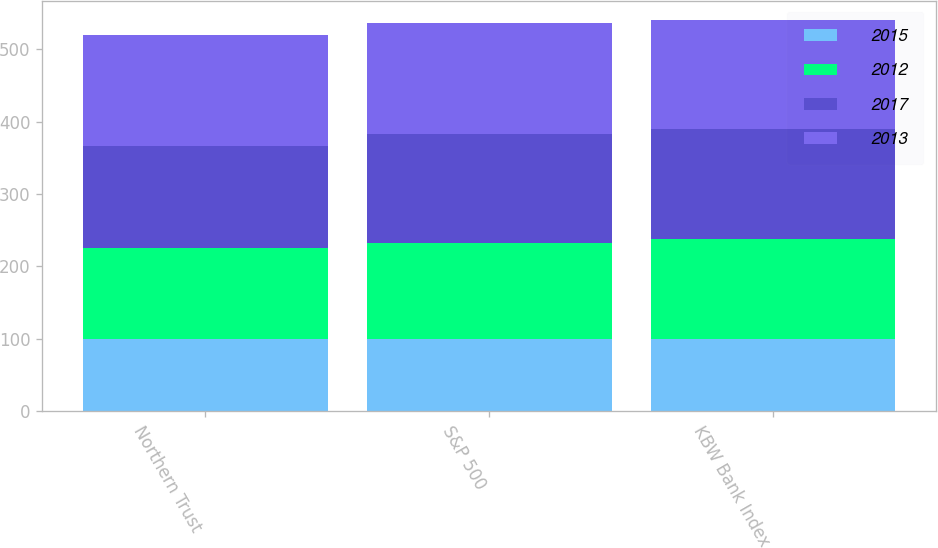Convert chart. <chart><loc_0><loc_0><loc_500><loc_500><stacked_bar_chart><ecel><fcel>Northern Trust<fcel>S&P 500<fcel>KBW Bank Index<nl><fcel>2015<fcel>100<fcel>100<fcel>100<nl><fcel>2012<fcel>126<fcel>132<fcel>138<nl><fcel>2017<fcel>140<fcel>151<fcel>151<nl><fcel>2013<fcel>153<fcel>153<fcel>151<nl></chart> 